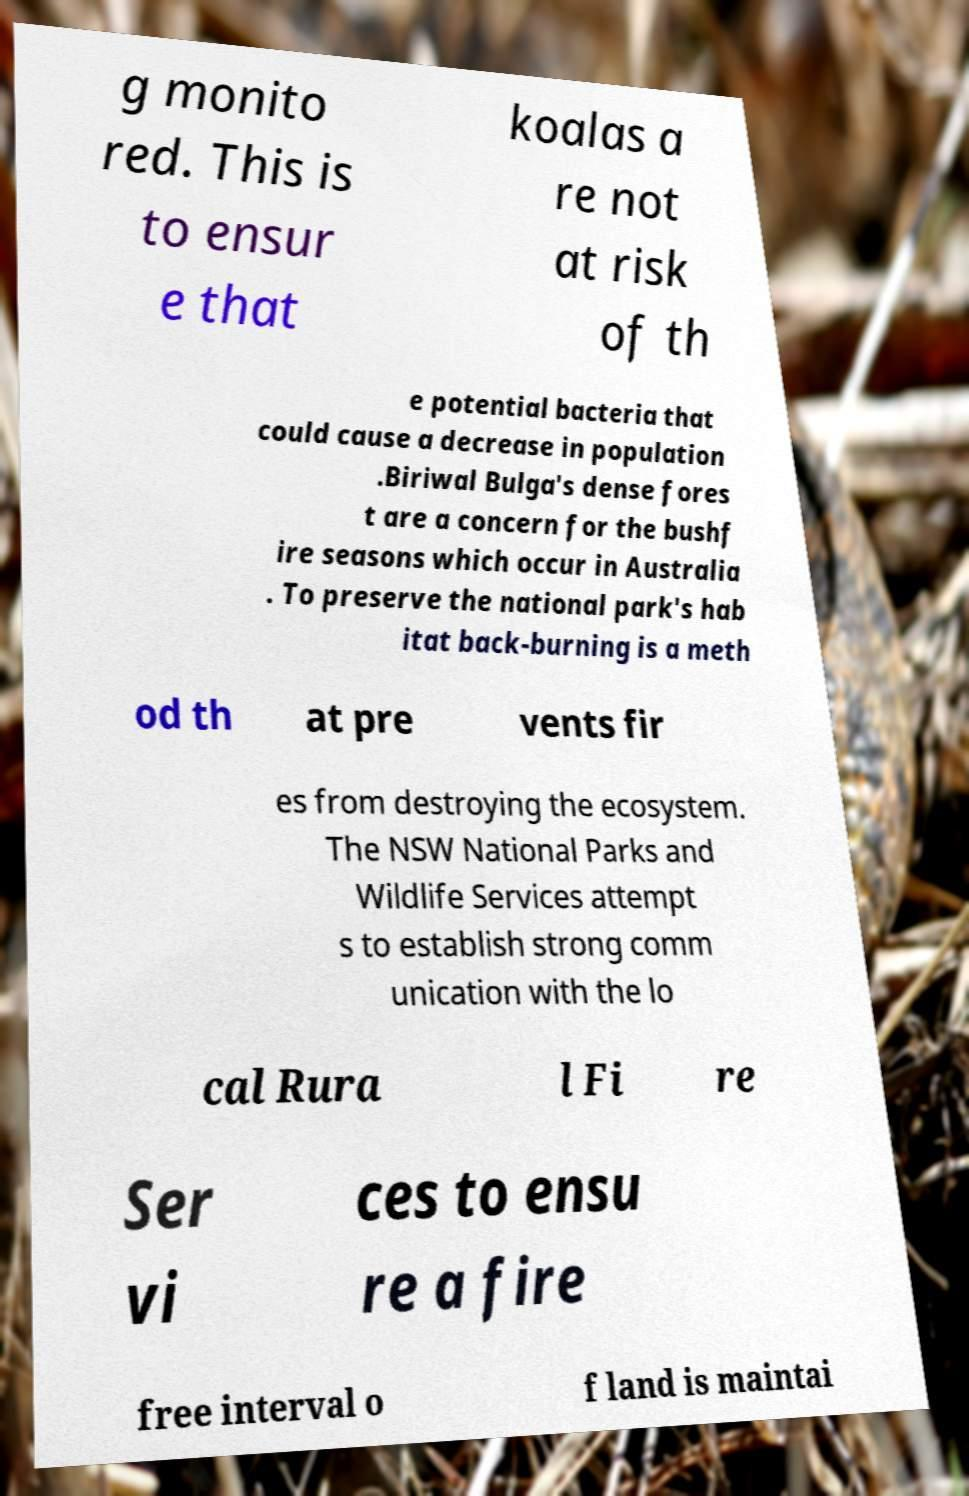Can you read and provide the text displayed in the image?This photo seems to have some interesting text. Can you extract and type it out for me? g monito red. This is to ensur e that koalas a re not at risk of th e potential bacteria that could cause a decrease in population .Biriwal Bulga's dense fores t are a concern for the bushf ire seasons which occur in Australia . To preserve the national park's hab itat back-burning is a meth od th at pre vents fir es from destroying the ecosystem. The NSW National Parks and Wildlife Services attempt s to establish strong comm unication with the lo cal Rura l Fi re Ser vi ces to ensu re a fire free interval o f land is maintai 